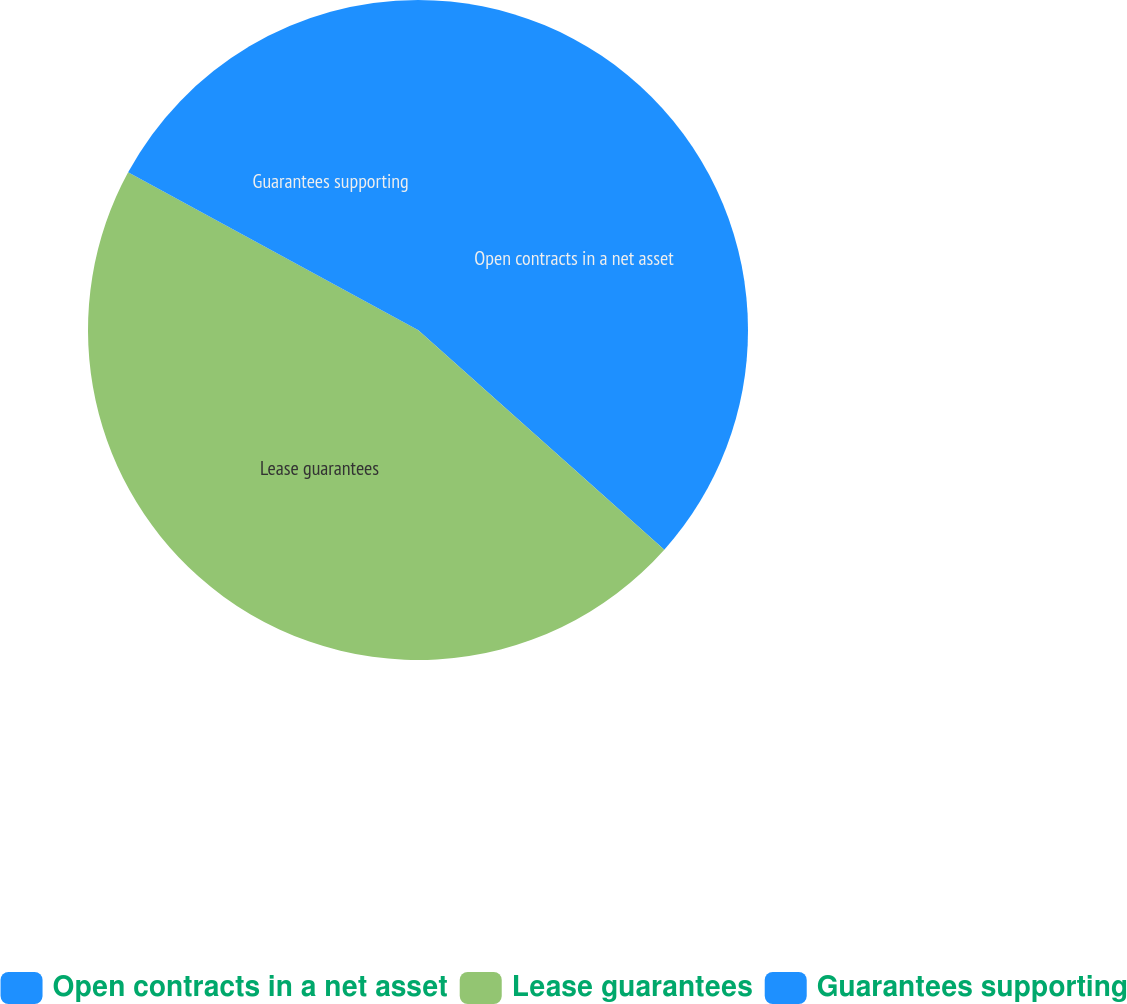<chart> <loc_0><loc_0><loc_500><loc_500><pie_chart><fcel>Open contracts in a net asset<fcel>Lease guarantees<fcel>Guarantees supporting<nl><fcel>36.59%<fcel>46.34%<fcel>17.07%<nl></chart> 